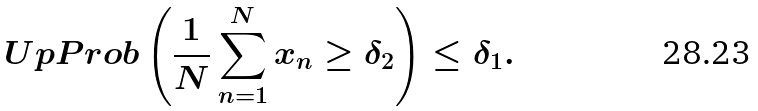Convert formula to latex. <formula><loc_0><loc_0><loc_500><loc_500>\ U p P r o b \left ( \frac { 1 } { N } \sum _ { n = 1 } ^ { N } x _ { n } \geq \delta _ { 2 } \right ) \leq \delta _ { 1 } .</formula> 